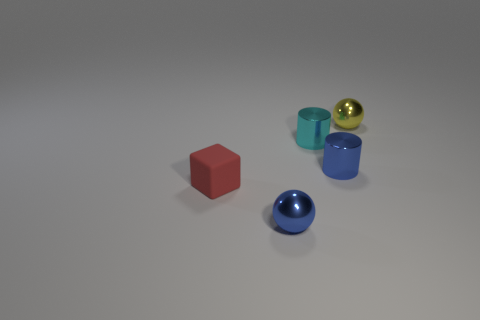What number of other tiny things have the same shape as the tiny rubber object?
Provide a short and direct response. 0. There is a cylinder that is made of the same material as the cyan thing; what is its size?
Your answer should be compact. Small. Does the red cube have the same size as the yellow metal ball?
Your answer should be compact. Yes. Are any small green metallic balls visible?
Make the answer very short. No. There is a matte block that is behind the tiny shiny sphere left of the cylinder that is on the left side of the blue cylinder; how big is it?
Ensure brevity in your answer.  Small. How many red things have the same material as the blue ball?
Ensure brevity in your answer.  0. What number of cyan balls are the same size as the yellow sphere?
Provide a short and direct response. 0. The small blue thing in front of the small blue metal thing that is behind the metallic thing in front of the red matte object is made of what material?
Provide a succinct answer. Metal. What number of objects are either small red blocks or large purple matte balls?
Give a very brief answer. 1. Are there any other things that have the same material as the cyan object?
Provide a short and direct response. Yes. 